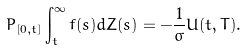<formula> <loc_0><loc_0><loc_500><loc_500>P _ { [ 0 , t ] } \int _ { t } ^ { \infty } f ( s ) d Z ( s ) = - \frac { 1 } { \sigma } U ( t , T ) .</formula> 